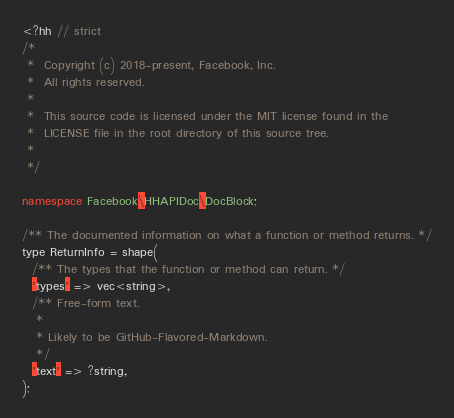<code> <loc_0><loc_0><loc_500><loc_500><_C++_><?hh // strict
/*
 *  Copyright (c) 2018-present, Facebook, Inc.
 *  All rights reserved.
 *
 *  This source code is licensed under the MIT license found in the
 *  LICENSE file in the root directory of this source tree.
 *
 */

namespace Facebook\HHAPIDoc\DocBlock;

/** The documented information on what a function or method returns. */
type ReturnInfo = shape(
  /** The types that the function or method can return. */
  'types' => vec<string>,
  /** Free-form text.
   *
   * Likely to be GitHub-Flavored-Markdown.
   */
  'text' => ?string,
);
</code> 